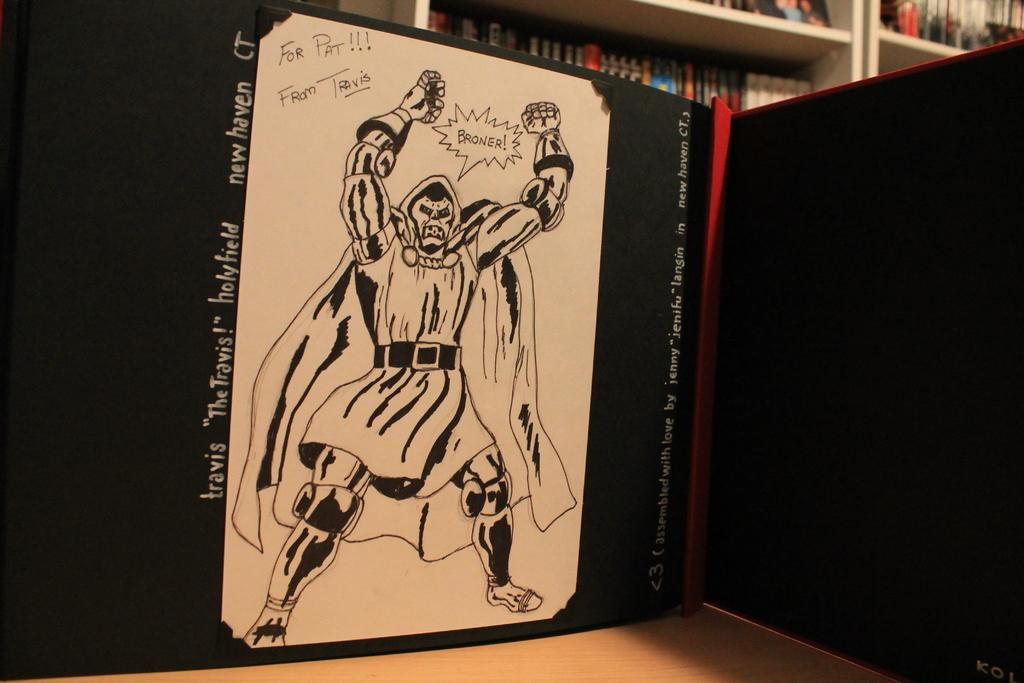<image>
Offer a succinct explanation of the picture presented. A book is signed for Pat from Travis. 